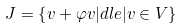Convert formula to latex. <formula><loc_0><loc_0><loc_500><loc_500>J = \left \{ v + \varphi v | d l e | v \in V \right \}</formula> 